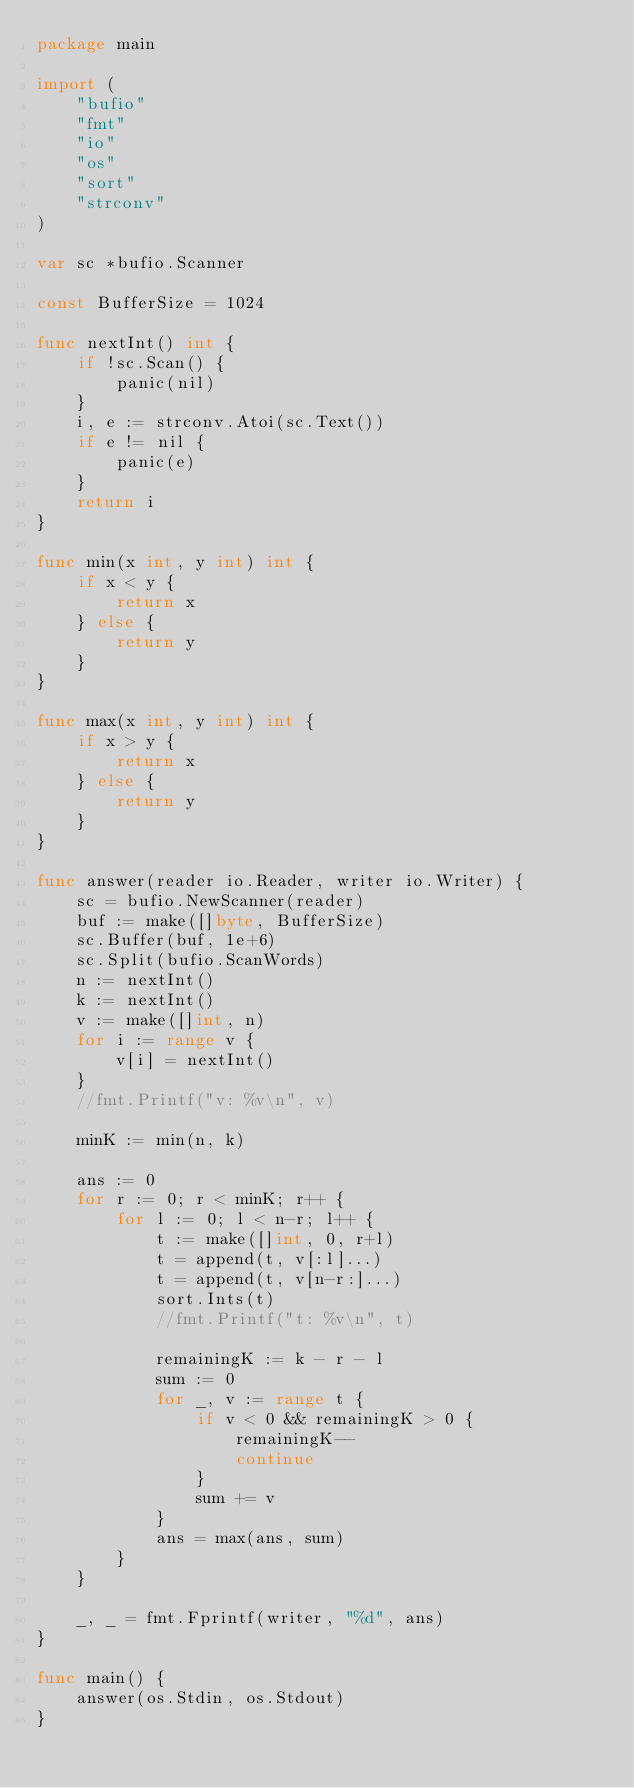<code> <loc_0><loc_0><loc_500><loc_500><_Go_>package main

import (
	"bufio"
	"fmt"
	"io"
	"os"
	"sort"
	"strconv"
)

var sc *bufio.Scanner

const BufferSize = 1024

func nextInt() int {
	if !sc.Scan() {
		panic(nil)
	}
	i, e := strconv.Atoi(sc.Text())
	if e != nil {
		panic(e)
	}
	return i
}

func min(x int, y int) int {
	if x < y {
		return x
	} else {
		return y
	}
}

func max(x int, y int) int {
	if x > y {
		return x
	} else {
		return y
	}
}

func answer(reader io.Reader, writer io.Writer) {
	sc = bufio.NewScanner(reader)
	buf := make([]byte, BufferSize)
	sc.Buffer(buf, 1e+6)
	sc.Split(bufio.ScanWords)
	n := nextInt()
	k := nextInt()
	v := make([]int, n)
	for i := range v {
		v[i] = nextInt()
	}
	//fmt.Printf("v: %v\n", v)

	minK := min(n, k)

	ans := 0
	for r := 0; r < minK; r++ {
		for l := 0; l < n-r; l++ {
			t := make([]int, 0, r+l)
			t = append(t, v[:l]...)
			t = append(t, v[n-r:]...)
			sort.Ints(t)
			//fmt.Printf("t: %v\n", t)

			remainingK := k - r - l
			sum := 0
			for _, v := range t {
				if v < 0 && remainingK > 0 {
					remainingK--
					continue
				}
				sum += v
			}
			ans = max(ans, sum)
		}
	}

	_, _ = fmt.Fprintf(writer, "%d", ans)
}

func main() {
	answer(os.Stdin, os.Stdout)
}
</code> 